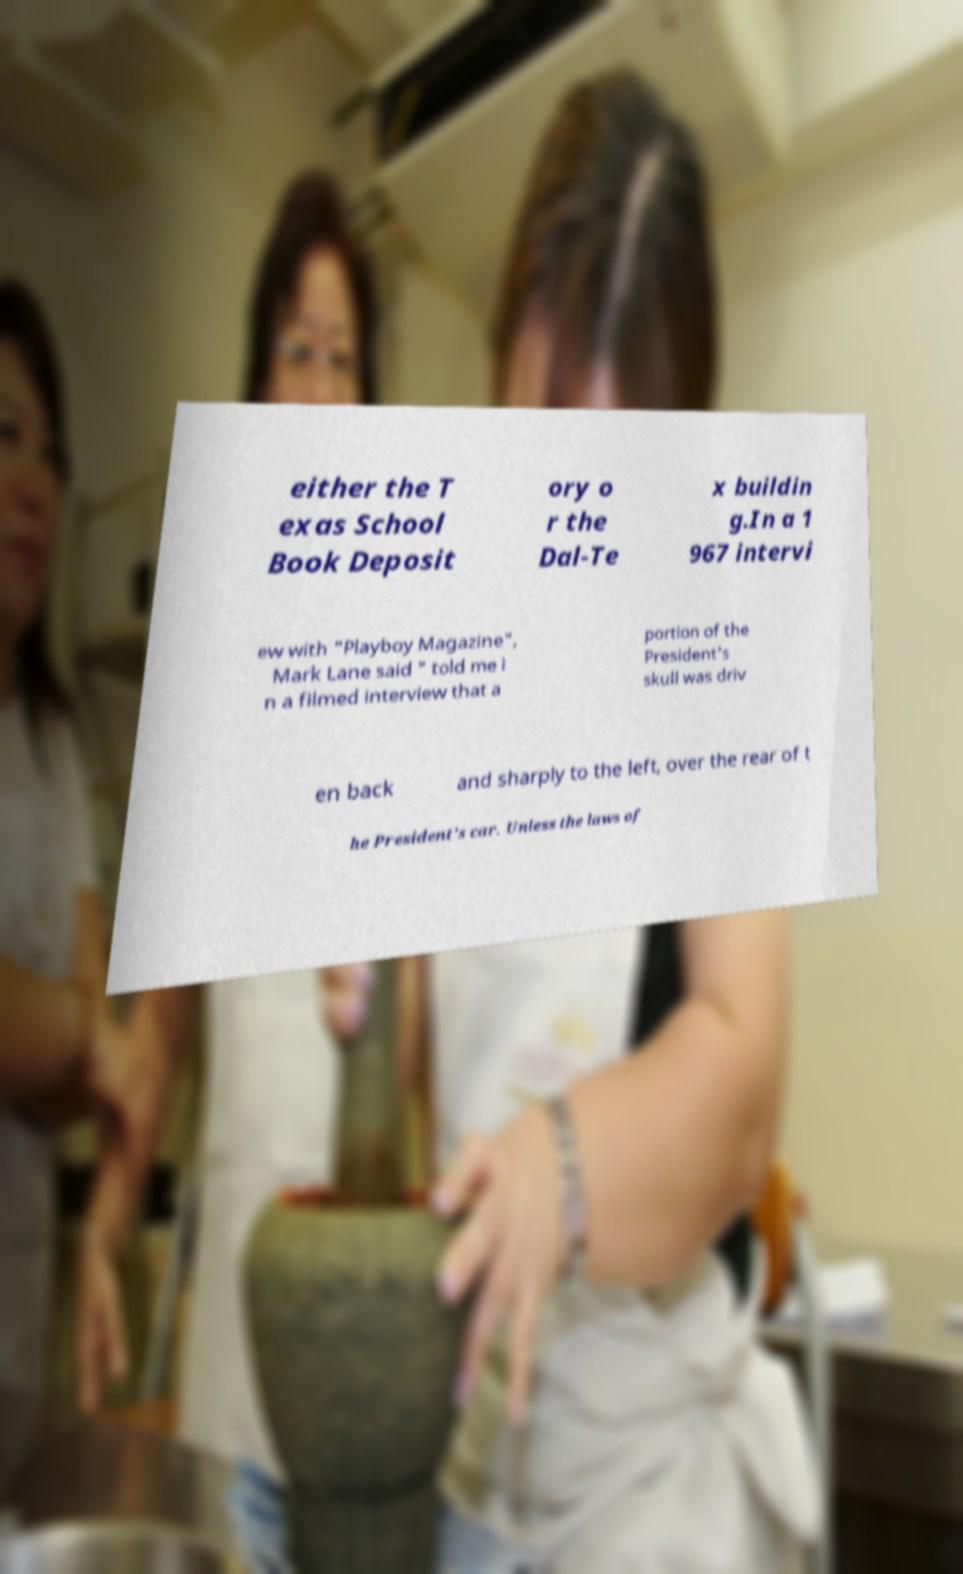Can you read and provide the text displayed in the image?This photo seems to have some interesting text. Can you extract and type it out for me? either the T exas School Book Deposit ory o r the Dal-Te x buildin g.In a 1 967 intervi ew with "Playboy Magazine", Mark Lane said " told me i n a filmed interview that a portion of the President's skull was driv en back and sharply to the left, over the rear of t he President's car. Unless the laws of 